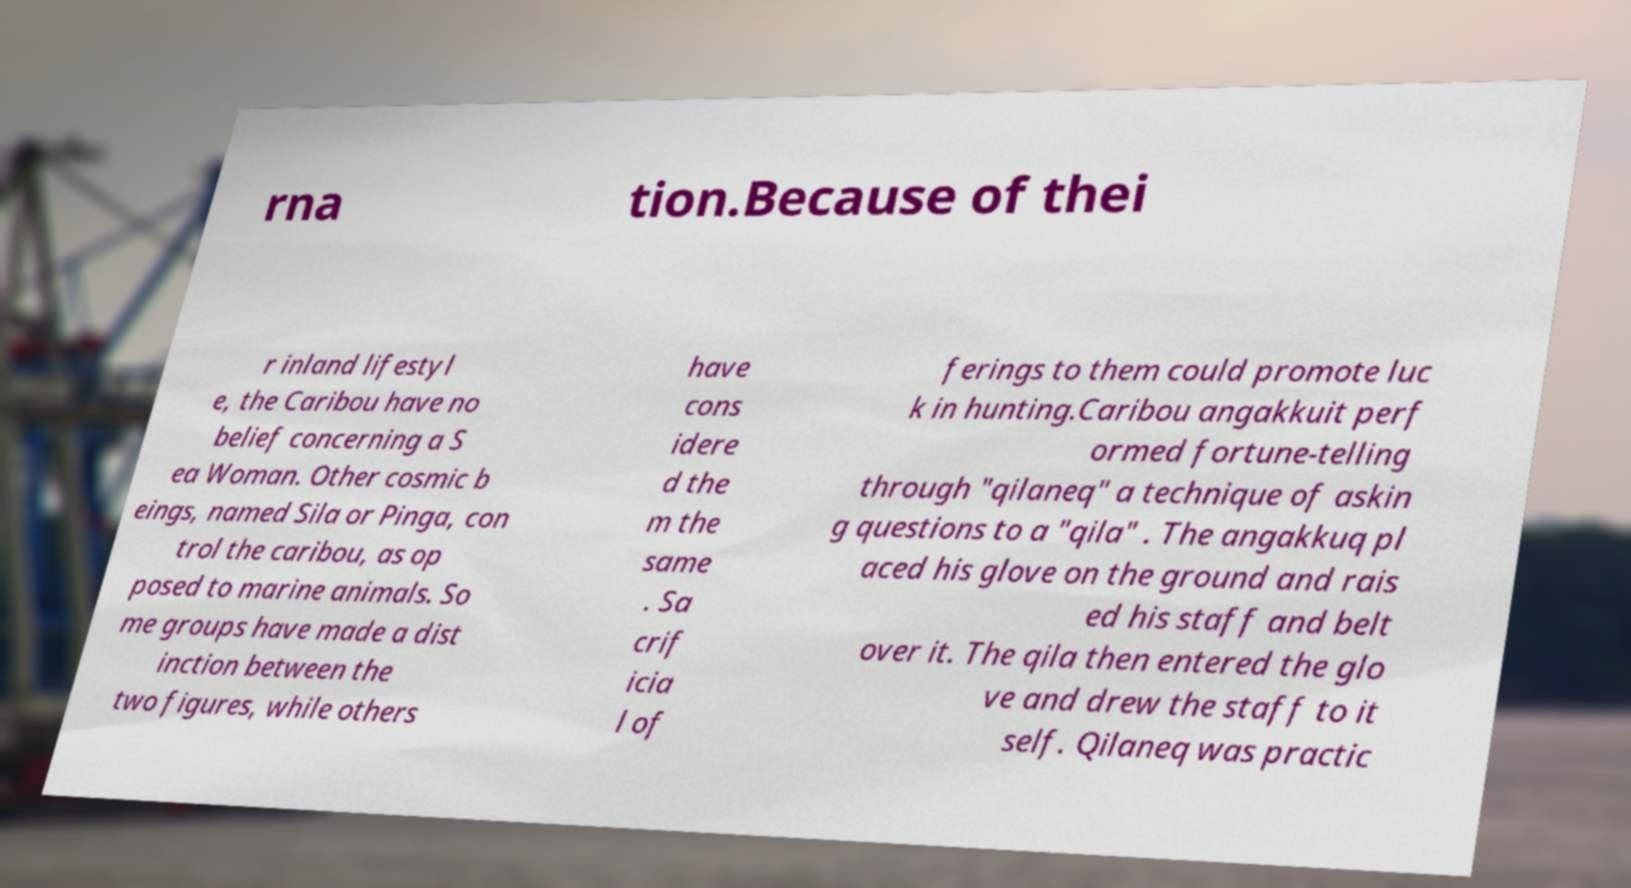Please read and relay the text visible in this image. What does it say? rna tion.Because of thei r inland lifestyl e, the Caribou have no belief concerning a S ea Woman. Other cosmic b eings, named Sila or Pinga, con trol the caribou, as op posed to marine animals. So me groups have made a dist inction between the two figures, while others have cons idere d the m the same . Sa crif icia l of ferings to them could promote luc k in hunting.Caribou angakkuit perf ormed fortune-telling through "qilaneq" a technique of askin g questions to a "qila" . The angakkuq pl aced his glove on the ground and rais ed his staff and belt over it. The qila then entered the glo ve and drew the staff to it self. Qilaneq was practic 